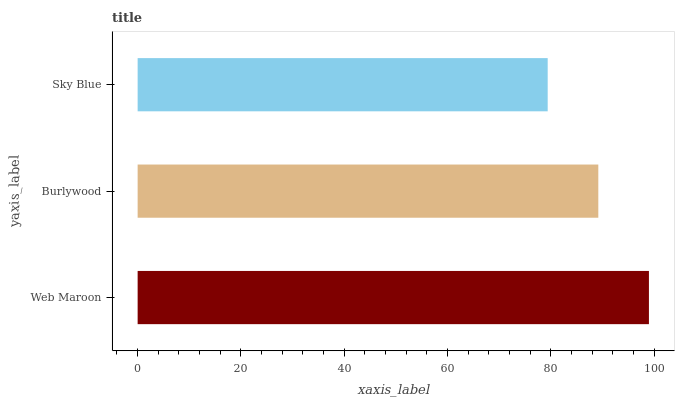Is Sky Blue the minimum?
Answer yes or no. Yes. Is Web Maroon the maximum?
Answer yes or no. Yes. Is Burlywood the minimum?
Answer yes or no. No. Is Burlywood the maximum?
Answer yes or no. No. Is Web Maroon greater than Burlywood?
Answer yes or no. Yes. Is Burlywood less than Web Maroon?
Answer yes or no. Yes. Is Burlywood greater than Web Maroon?
Answer yes or no. No. Is Web Maroon less than Burlywood?
Answer yes or no. No. Is Burlywood the high median?
Answer yes or no. Yes. Is Burlywood the low median?
Answer yes or no. Yes. Is Web Maroon the high median?
Answer yes or no. No. Is Sky Blue the low median?
Answer yes or no. No. 